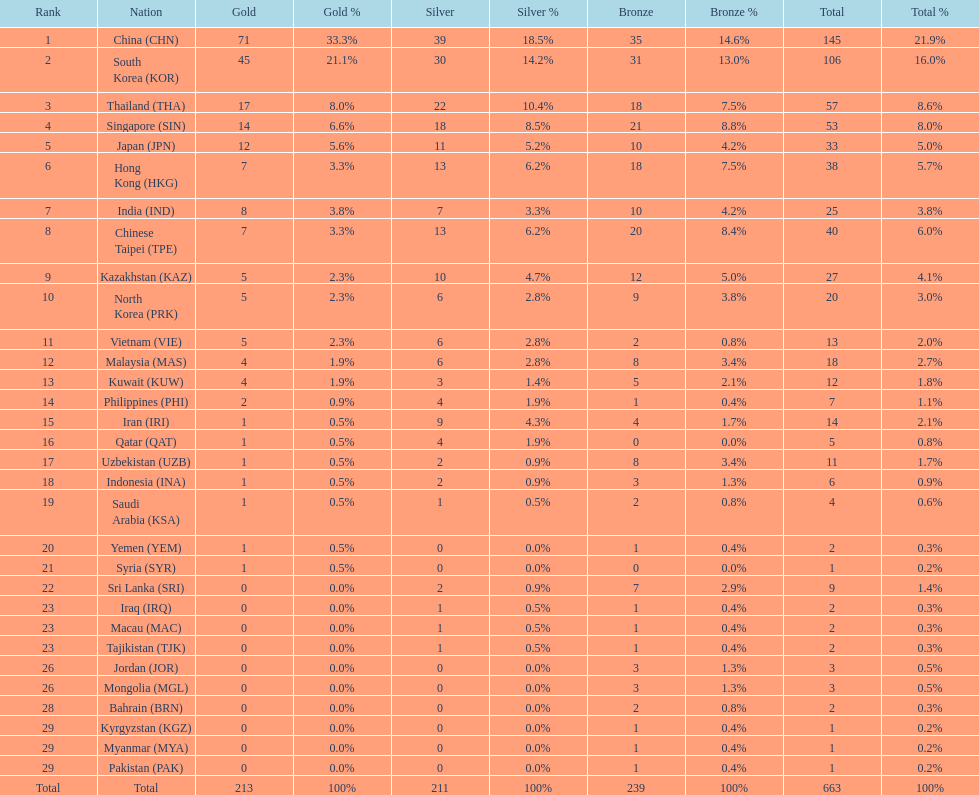How many nations earned at least ten bronze medals? 9. 